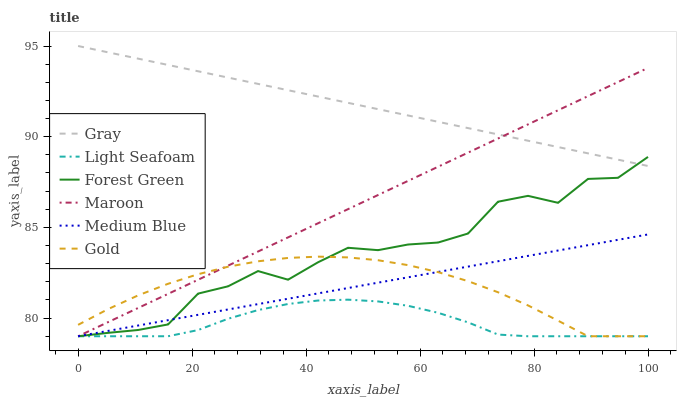Does Light Seafoam have the minimum area under the curve?
Answer yes or no. Yes. Does Gray have the maximum area under the curve?
Answer yes or no. Yes. Does Gold have the minimum area under the curve?
Answer yes or no. No. Does Gold have the maximum area under the curve?
Answer yes or no. No. Is Gray the smoothest?
Answer yes or no. Yes. Is Forest Green the roughest?
Answer yes or no. Yes. Is Gold the smoothest?
Answer yes or no. No. Is Gold the roughest?
Answer yes or no. No. Does Gold have the lowest value?
Answer yes or no. Yes. Does Gray have the highest value?
Answer yes or no. Yes. Does Gold have the highest value?
Answer yes or no. No. Is Gold less than Gray?
Answer yes or no. Yes. Is Gray greater than Gold?
Answer yes or no. Yes. Does Light Seafoam intersect Medium Blue?
Answer yes or no. Yes. Is Light Seafoam less than Medium Blue?
Answer yes or no. No. Is Light Seafoam greater than Medium Blue?
Answer yes or no. No. Does Gold intersect Gray?
Answer yes or no. No. 